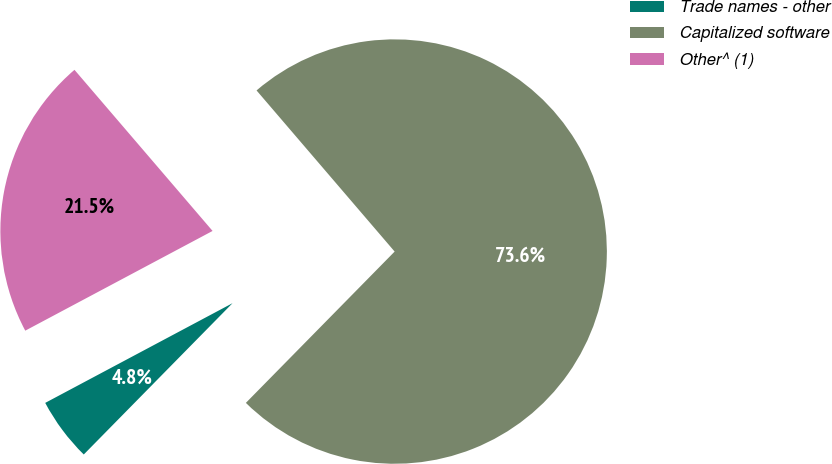Convert chart. <chart><loc_0><loc_0><loc_500><loc_500><pie_chart><fcel>Trade names - other<fcel>Capitalized software<fcel>Other^ (1)<nl><fcel>4.85%<fcel>73.65%<fcel>21.51%<nl></chart> 